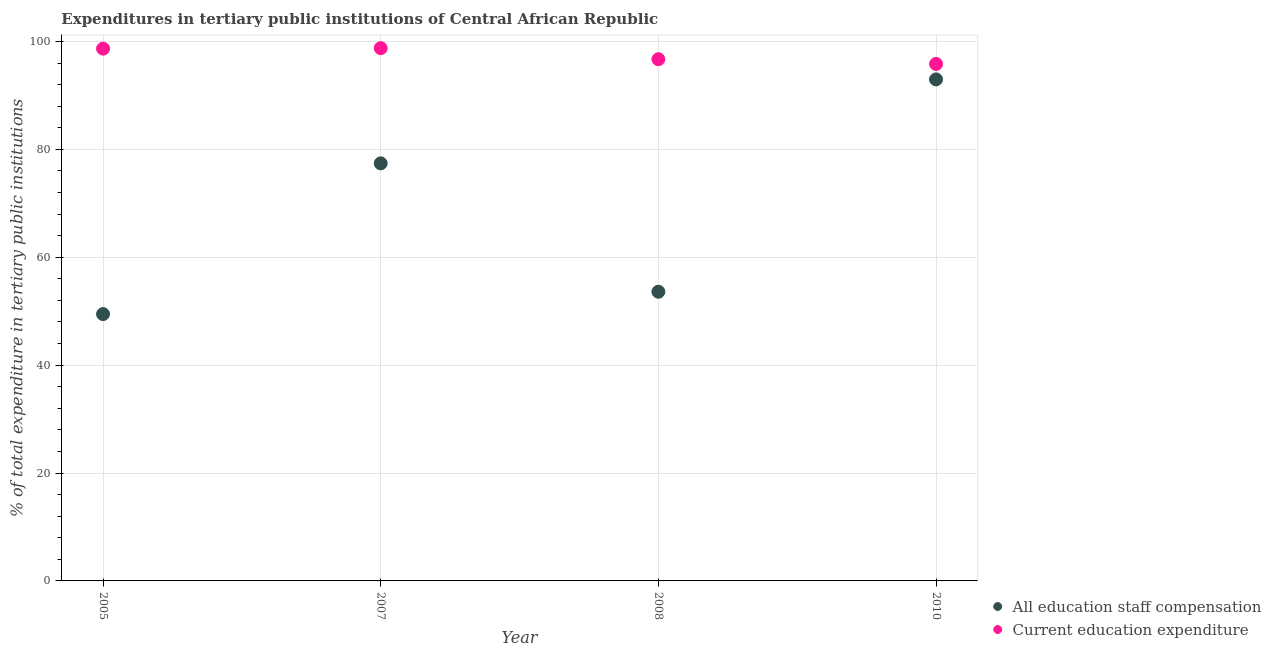How many different coloured dotlines are there?
Provide a succinct answer. 2. What is the expenditure in education in 2005?
Offer a very short reply. 98.68. Across all years, what is the maximum expenditure in education?
Offer a terse response. 98.76. Across all years, what is the minimum expenditure in staff compensation?
Provide a short and direct response. 49.46. What is the total expenditure in staff compensation in the graph?
Make the answer very short. 273.45. What is the difference between the expenditure in staff compensation in 2008 and that in 2010?
Provide a short and direct response. -39.36. What is the difference between the expenditure in education in 2007 and the expenditure in staff compensation in 2005?
Keep it short and to the point. 49.3. What is the average expenditure in education per year?
Your response must be concise. 97.49. In the year 2007, what is the difference between the expenditure in staff compensation and expenditure in education?
Provide a succinct answer. -21.35. What is the ratio of the expenditure in staff compensation in 2005 to that in 2010?
Provide a short and direct response. 0.53. Is the expenditure in education in 2008 less than that in 2010?
Give a very brief answer. No. Is the difference between the expenditure in education in 2007 and 2010 greater than the difference between the expenditure in staff compensation in 2007 and 2010?
Offer a very short reply. Yes. What is the difference between the highest and the second highest expenditure in staff compensation?
Keep it short and to the point. 15.56. What is the difference between the highest and the lowest expenditure in staff compensation?
Offer a terse response. 43.51. Is the sum of the expenditure in staff compensation in 2005 and 2008 greater than the maximum expenditure in education across all years?
Offer a very short reply. Yes. Is the expenditure in staff compensation strictly greater than the expenditure in education over the years?
Make the answer very short. No. How many years are there in the graph?
Offer a very short reply. 4. What is the difference between two consecutive major ticks on the Y-axis?
Your response must be concise. 20. Are the values on the major ticks of Y-axis written in scientific E-notation?
Offer a very short reply. No. Does the graph contain any zero values?
Your response must be concise. No. Where does the legend appear in the graph?
Make the answer very short. Bottom right. How many legend labels are there?
Make the answer very short. 2. How are the legend labels stacked?
Offer a very short reply. Vertical. What is the title of the graph?
Offer a very short reply. Expenditures in tertiary public institutions of Central African Republic. What is the label or title of the X-axis?
Give a very brief answer. Year. What is the label or title of the Y-axis?
Keep it short and to the point. % of total expenditure in tertiary public institutions. What is the % of total expenditure in tertiary public institutions of All education staff compensation in 2005?
Your response must be concise. 49.46. What is the % of total expenditure in tertiary public institutions in Current education expenditure in 2005?
Keep it short and to the point. 98.68. What is the % of total expenditure in tertiary public institutions in All education staff compensation in 2007?
Ensure brevity in your answer.  77.41. What is the % of total expenditure in tertiary public institutions of Current education expenditure in 2007?
Your response must be concise. 98.76. What is the % of total expenditure in tertiary public institutions in All education staff compensation in 2008?
Your answer should be compact. 53.61. What is the % of total expenditure in tertiary public institutions in Current education expenditure in 2008?
Ensure brevity in your answer.  96.71. What is the % of total expenditure in tertiary public institutions of All education staff compensation in 2010?
Offer a terse response. 92.97. What is the % of total expenditure in tertiary public institutions in Current education expenditure in 2010?
Keep it short and to the point. 95.83. Across all years, what is the maximum % of total expenditure in tertiary public institutions of All education staff compensation?
Give a very brief answer. 92.97. Across all years, what is the maximum % of total expenditure in tertiary public institutions of Current education expenditure?
Your response must be concise. 98.76. Across all years, what is the minimum % of total expenditure in tertiary public institutions in All education staff compensation?
Keep it short and to the point. 49.46. Across all years, what is the minimum % of total expenditure in tertiary public institutions in Current education expenditure?
Give a very brief answer. 95.83. What is the total % of total expenditure in tertiary public institutions of All education staff compensation in the graph?
Make the answer very short. 273.45. What is the total % of total expenditure in tertiary public institutions in Current education expenditure in the graph?
Your response must be concise. 389.98. What is the difference between the % of total expenditure in tertiary public institutions in All education staff compensation in 2005 and that in 2007?
Offer a terse response. -27.94. What is the difference between the % of total expenditure in tertiary public institutions of Current education expenditure in 2005 and that in 2007?
Your response must be concise. -0.08. What is the difference between the % of total expenditure in tertiary public institutions in All education staff compensation in 2005 and that in 2008?
Give a very brief answer. -4.14. What is the difference between the % of total expenditure in tertiary public institutions in Current education expenditure in 2005 and that in 2008?
Offer a very short reply. 1.97. What is the difference between the % of total expenditure in tertiary public institutions in All education staff compensation in 2005 and that in 2010?
Offer a very short reply. -43.51. What is the difference between the % of total expenditure in tertiary public institutions of Current education expenditure in 2005 and that in 2010?
Your answer should be compact. 2.84. What is the difference between the % of total expenditure in tertiary public institutions of All education staff compensation in 2007 and that in 2008?
Offer a very short reply. 23.8. What is the difference between the % of total expenditure in tertiary public institutions in Current education expenditure in 2007 and that in 2008?
Offer a terse response. 2.05. What is the difference between the % of total expenditure in tertiary public institutions in All education staff compensation in 2007 and that in 2010?
Ensure brevity in your answer.  -15.56. What is the difference between the % of total expenditure in tertiary public institutions in Current education expenditure in 2007 and that in 2010?
Give a very brief answer. 2.93. What is the difference between the % of total expenditure in tertiary public institutions of All education staff compensation in 2008 and that in 2010?
Your answer should be very brief. -39.36. What is the difference between the % of total expenditure in tertiary public institutions in Current education expenditure in 2008 and that in 2010?
Keep it short and to the point. 0.88. What is the difference between the % of total expenditure in tertiary public institutions in All education staff compensation in 2005 and the % of total expenditure in tertiary public institutions in Current education expenditure in 2007?
Your response must be concise. -49.3. What is the difference between the % of total expenditure in tertiary public institutions in All education staff compensation in 2005 and the % of total expenditure in tertiary public institutions in Current education expenditure in 2008?
Ensure brevity in your answer.  -47.25. What is the difference between the % of total expenditure in tertiary public institutions of All education staff compensation in 2005 and the % of total expenditure in tertiary public institutions of Current education expenditure in 2010?
Keep it short and to the point. -46.37. What is the difference between the % of total expenditure in tertiary public institutions in All education staff compensation in 2007 and the % of total expenditure in tertiary public institutions in Current education expenditure in 2008?
Give a very brief answer. -19.3. What is the difference between the % of total expenditure in tertiary public institutions of All education staff compensation in 2007 and the % of total expenditure in tertiary public institutions of Current education expenditure in 2010?
Your answer should be compact. -18.42. What is the difference between the % of total expenditure in tertiary public institutions of All education staff compensation in 2008 and the % of total expenditure in tertiary public institutions of Current education expenditure in 2010?
Offer a terse response. -42.23. What is the average % of total expenditure in tertiary public institutions in All education staff compensation per year?
Offer a very short reply. 68.36. What is the average % of total expenditure in tertiary public institutions of Current education expenditure per year?
Give a very brief answer. 97.49. In the year 2005, what is the difference between the % of total expenditure in tertiary public institutions of All education staff compensation and % of total expenditure in tertiary public institutions of Current education expenditure?
Provide a short and direct response. -49.21. In the year 2007, what is the difference between the % of total expenditure in tertiary public institutions of All education staff compensation and % of total expenditure in tertiary public institutions of Current education expenditure?
Provide a succinct answer. -21.35. In the year 2008, what is the difference between the % of total expenditure in tertiary public institutions of All education staff compensation and % of total expenditure in tertiary public institutions of Current education expenditure?
Your answer should be very brief. -43.1. In the year 2010, what is the difference between the % of total expenditure in tertiary public institutions of All education staff compensation and % of total expenditure in tertiary public institutions of Current education expenditure?
Provide a succinct answer. -2.86. What is the ratio of the % of total expenditure in tertiary public institutions of All education staff compensation in 2005 to that in 2007?
Your response must be concise. 0.64. What is the ratio of the % of total expenditure in tertiary public institutions in Current education expenditure in 2005 to that in 2007?
Offer a very short reply. 1. What is the ratio of the % of total expenditure in tertiary public institutions in All education staff compensation in 2005 to that in 2008?
Provide a short and direct response. 0.92. What is the ratio of the % of total expenditure in tertiary public institutions of Current education expenditure in 2005 to that in 2008?
Provide a succinct answer. 1.02. What is the ratio of the % of total expenditure in tertiary public institutions of All education staff compensation in 2005 to that in 2010?
Ensure brevity in your answer.  0.53. What is the ratio of the % of total expenditure in tertiary public institutions of Current education expenditure in 2005 to that in 2010?
Give a very brief answer. 1.03. What is the ratio of the % of total expenditure in tertiary public institutions in All education staff compensation in 2007 to that in 2008?
Give a very brief answer. 1.44. What is the ratio of the % of total expenditure in tertiary public institutions of Current education expenditure in 2007 to that in 2008?
Make the answer very short. 1.02. What is the ratio of the % of total expenditure in tertiary public institutions of All education staff compensation in 2007 to that in 2010?
Keep it short and to the point. 0.83. What is the ratio of the % of total expenditure in tertiary public institutions of Current education expenditure in 2007 to that in 2010?
Your answer should be compact. 1.03. What is the ratio of the % of total expenditure in tertiary public institutions in All education staff compensation in 2008 to that in 2010?
Give a very brief answer. 0.58. What is the ratio of the % of total expenditure in tertiary public institutions of Current education expenditure in 2008 to that in 2010?
Provide a short and direct response. 1.01. What is the difference between the highest and the second highest % of total expenditure in tertiary public institutions of All education staff compensation?
Make the answer very short. 15.56. What is the difference between the highest and the second highest % of total expenditure in tertiary public institutions in Current education expenditure?
Offer a very short reply. 0.08. What is the difference between the highest and the lowest % of total expenditure in tertiary public institutions in All education staff compensation?
Give a very brief answer. 43.51. What is the difference between the highest and the lowest % of total expenditure in tertiary public institutions of Current education expenditure?
Your answer should be compact. 2.93. 